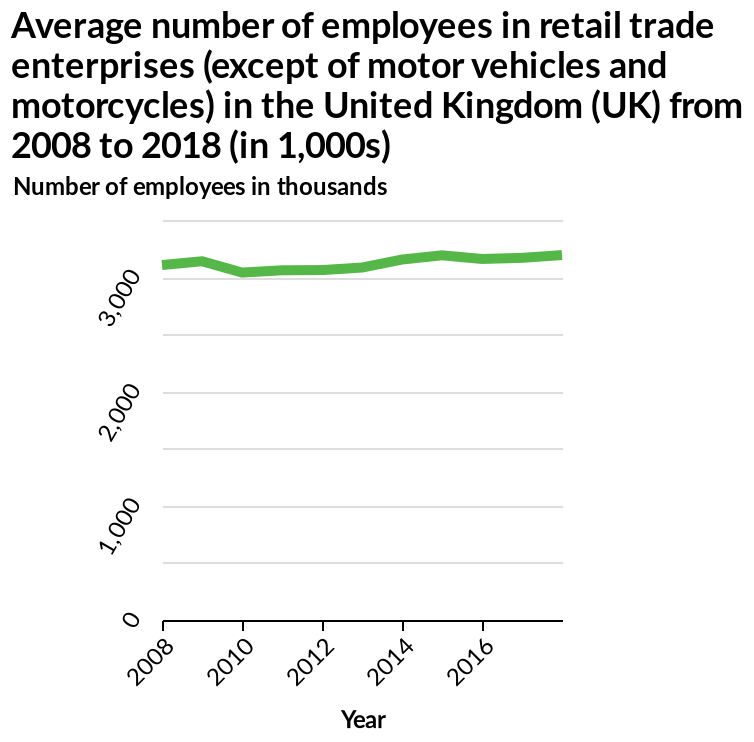<image>
What is the title of the line graph?  The title of the line graph is "Average number of employees in retail trade enterprises (except of motor vehicles and motorcycles) in the United Kingdom (UK) from 2008 to 2018 (in 1,000s)." 